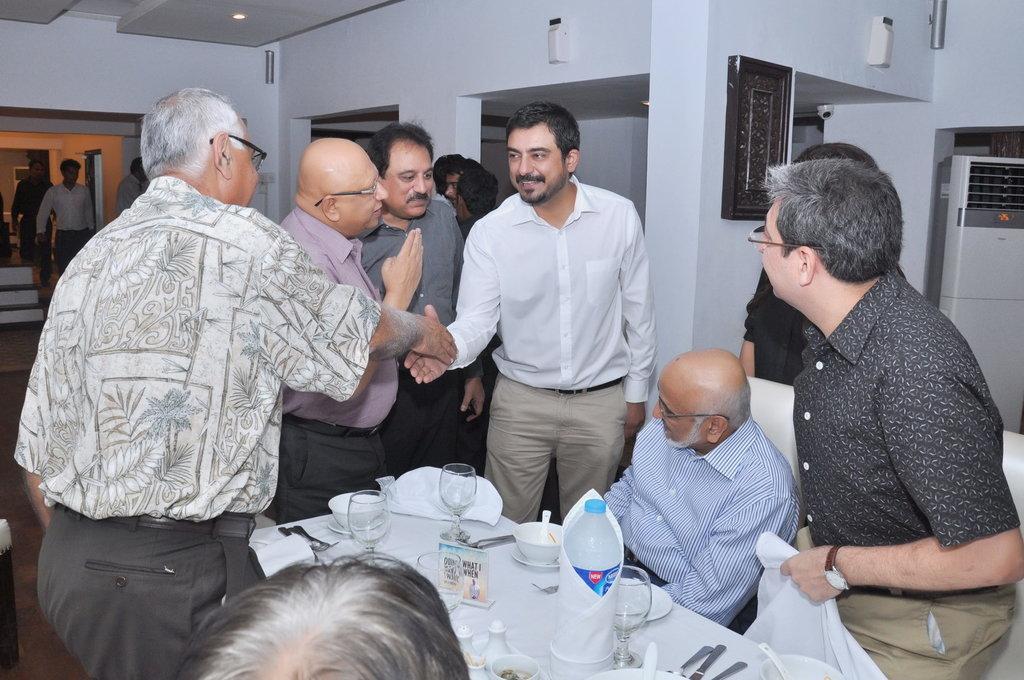Can you describe this image briefly? In this image there are a group of people who are standing, and there are two persons who are shaking their hands with each other. And two persons are sitting on chairs and there is one table, on the table there are some glasses, bowls, spoons, bottle and some other objects. And in the background there are some persons, photo frame on the wall, and on the right side there is some object and in the background there is a wall and on the left side there are some stairs. At the top there is ceiling and lights, and also on the wall there are some objects. At the bottom there is floor. 